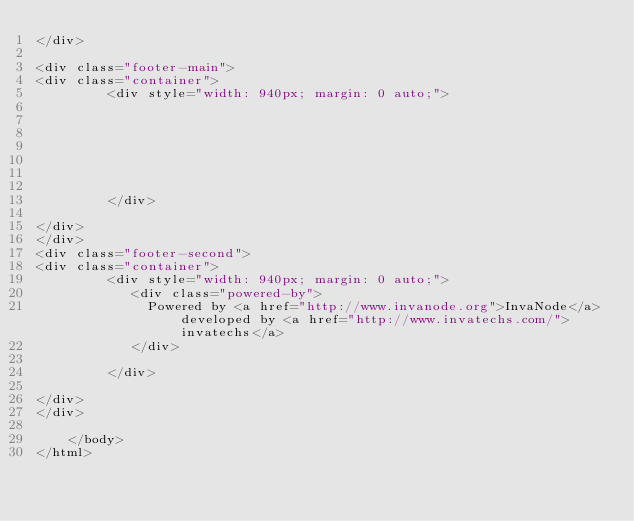<code> <loc_0><loc_0><loc_500><loc_500><_HTML_></div>

<div class="footer-main">
<div class="container">
         <div style="width: 940px; margin: 0 auto;">
             
             
             
             
             
             
             
         </div>
    
</div>
</div>
<div class="footer-second">
<div class="container">
         <div style="width: 940px; margin: 0 auto;">
            <div class="powered-by"> 
              Powered by <a href="http://www.invanode.org">InvaNode</a> developed by <a href="http://www.invatechs.com/">invatechs</a> 
            </div> 
             
         </div>
    
</div>
</div>
      
    </body>
</html>
</code> 